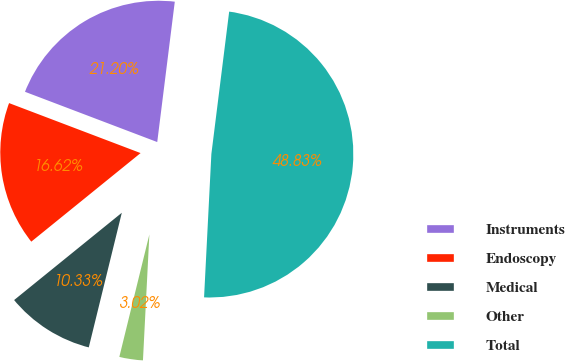<chart> <loc_0><loc_0><loc_500><loc_500><pie_chart><fcel>Instruments<fcel>Endoscopy<fcel>Medical<fcel>Other<fcel>Total<nl><fcel>21.2%<fcel>16.62%<fcel>10.33%<fcel>3.02%<fcel>48.83%<nl></chart> 